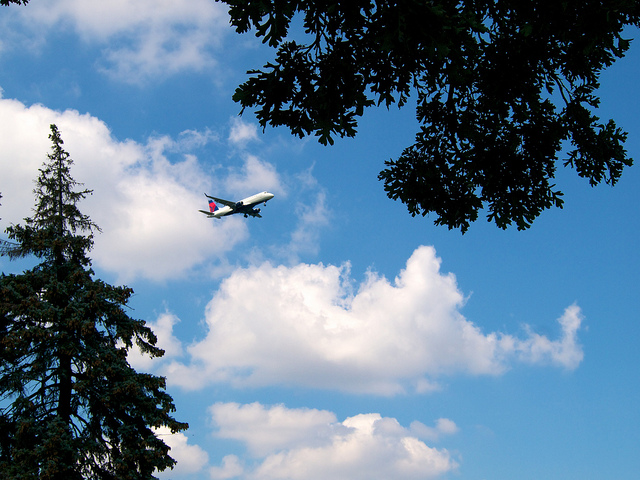<image>There are two different colored umbrellas. What are they? There are no umbrellas in the image. What animal is shown? There is no animal in the image. However, it can be a bird. Is there a kite in the image? There is no kite in the image. What is the main color of this train? There is no train in the image. There are two different colored umbrellas. What are they? It is ambiguous the colors of the umbrellas. They can be seen red and white or blue. What animal is shown? There is no animal shown in the image. Is there a kite in the image? There is no kite in the image. What is the main color of this train? It is unanswerable what is the main color of the train. There is no train in the image. 